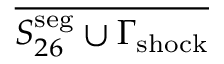Convert formula to latex. <formula><loc_0><loc_0><loc_500><loc_500>\overline { { S _ { 2 6 } ^ { s e g } \cup \Gamma _ { s h o c k } } }</formula> 